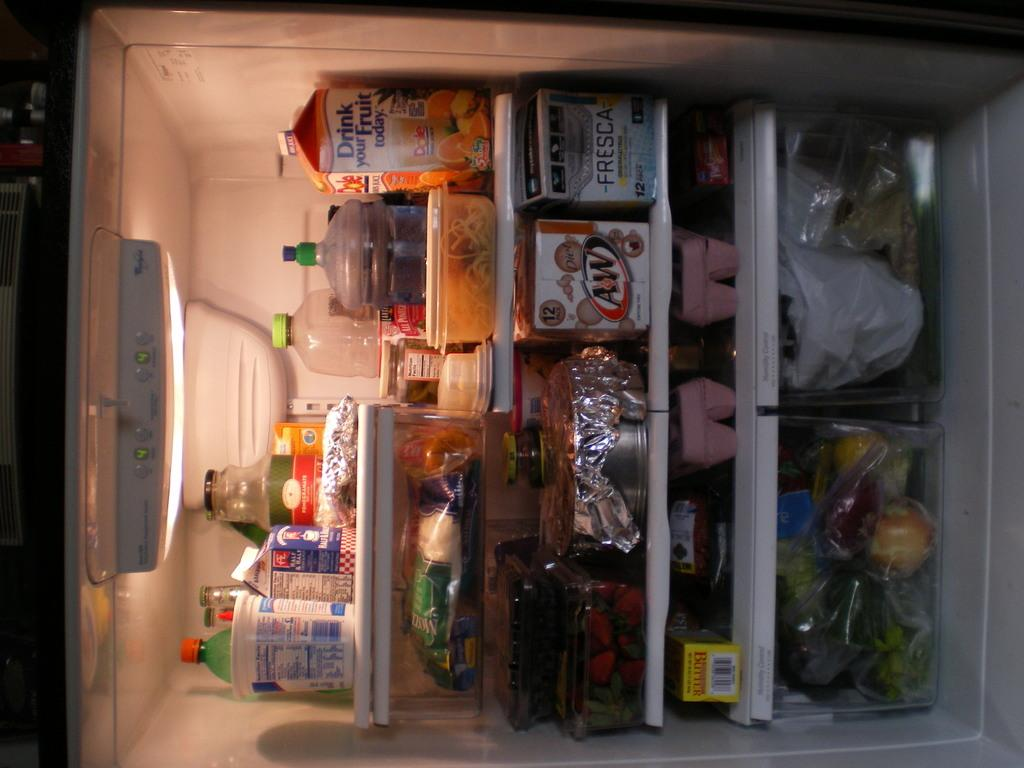<image>
Provide a brief description of the given image. refrigerator that has a carton of Dole juice and carton of diet a&w 